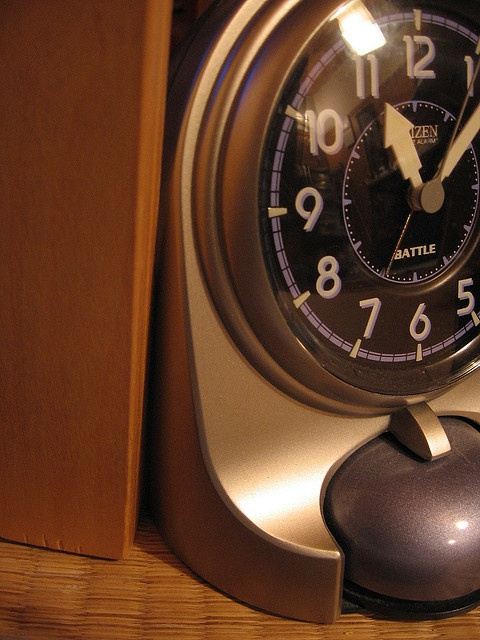Describe the objects in this image and their specific colors. I can see a clock in maroon, black, and gray tones in this image. 